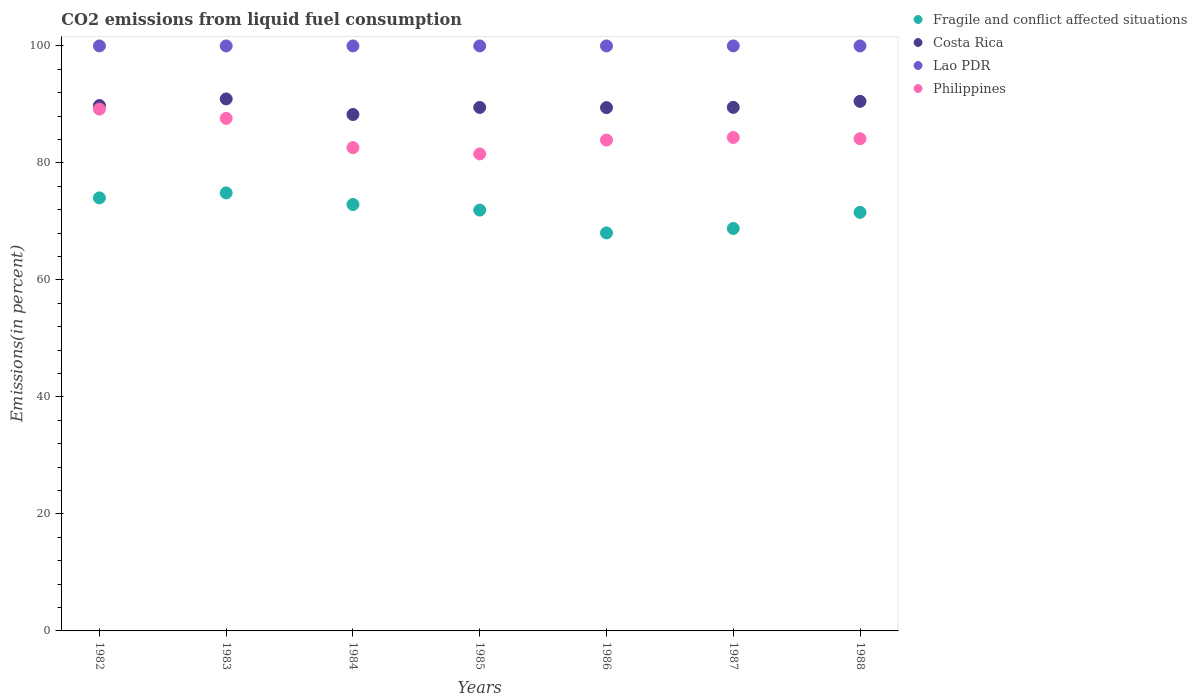How many different coloured dotlines are there?
Offer a very short reply. 4. What is the total CO2 emitted in Costa Rica in 1988?
Your response must be concise. 90.52. Across all years, what is the maximum total CO2 emitted in Fragile and conflict affected situations?
Make the answer very short. 74.87. Across all years, what is the minimum total CO2 emitted in Fragile and conflict affected situations?
Offer a terse response. 68.04. What is the total total CO2 emitted in Fragile and conflict affected situations in the graph?
Offer a terse response. 502.1. What is the difference between the total CO2 emitted in Fragile and conflict affected situations in 1985 and that in 1986?
Provide a short and direct response. 3.9. What is the difference between the total CO2 emitted in Philippines in 1988 and the total CO2 emitted in Fragile and conflict affected situations in 1986?
Make the answer very short. 16.1. What is the average total CO2 emitted in Costa Rica per year?
Ensure brevity in your answer.  89.71. In the year 1983, what is the difference between the total CO2 emitted in Costa Rica and total CO2 emitted in Fragile and conflict affected situations?
Offer a terse response. 16.07. In how many years, is the total CO2 emitted in Lao PDR greater than 68 %?
Your answer should be very brief. 7. What is the ratio of the total CO2 emitted in Costa Rica in 1983 to that in 1988?
Offer a terse response. 1. Is the difference between the total CO2 emitted in Costa Rica in 1983 and 1984 greater than the difference between the total CO2 emitted in Fragile and conflict affected situations in 1983 and 1984?
Provide a succinct answer. Yes. What is the difference between the highest and the second highest total CO2 emitted in Costa Rica?
Offer a very short reply. 0.42. What is the difference between the highest and the lowest total CO2 emitted in Philippines?
Give a very brief answer. 7.66. In how many years, is the total CO2 emitted in Philippines greater than the average total CO2 emitted in Philippines taken over all years?
Provide a short and direct response. 2. Is the sum of the total CO2 emitted in Philippines in 1984 and 1986 greater than the maximum total CO2 emitted in Costa Rica across all years?
Your response must be concise. Yes. Is it the case that in every year, the sum of the total CO2 emitted in Lao PDR and total CO2 emitted in Philippines  is greater than the sum of total CO2 emitted in Costa Rica and total CO2 emitted in Fragile and conflict affected situations?
Make the answer very short. Yes. Is the total CO2 emitted in Lao PDR strictly greater than the total CO2 emitted in Fragile and conflict affected situations over the years?
Provide a short and direct response. Yes. Is the total CO2 emitted in Philippines strictly less than the total CO2 emitted in Costa Rica over the years?
Your response must be concise. Yes. Does the graph contain grids?
Provide a succinct answer. No. Where does the legend appear in the graph?
Your answer should be compact. Top right. How many legend labels are there?
Your answer should be compact. 4. How are the legend labels stacked?
Keep it short and to the point. Vertical. What is the title of the graph?
Make the answer very short. CO2 emissions from liquid fuel consumption. Does "Lithuania" appear as one of the legend labels in the graph?
Ensure brevity in your answer.  No. What is the label or title of the Y-axis?
Offer a very short reply. Emissions(in percent). What is the Emissions(in percent) of Fragile and conflict affected situations in 1982?
Offer a very short reply. 74.03. What is the Emissions(in percent) of Costa Rica in 1982?
Make the answer very short. 89.81. What is the Emissions(in percent) of Lao PDR in 1982?
Offer a terse response. 100. What is the Emissions(in percent) in Philippines in 1982?
Offer a terse response. 89.2. What is the Emissions(in percent) in Fragile and conflict affected situations in 1983?
Offer a very short reply. 74.87. What is the Emissions(in percent) of Costa Rica in 1983?
Give a very brief answer. 90.94. What is the Emissions(in percent) in Philippines in 1983?
Keep it short and to the point. 87.62. What is the Emissions(in percent) of Fragile and conflict affected situations in 1984?
Give a very brief answer. 72.89. What is the Emissions(in percent) in Costa Rica in 1984?
Your answer should be very brief. 88.28. What is the Emissions(in percent) in Philippines in 1984?
Provide a succinct answer. 82.62. What is the Emissions(in percent) in Fragile and conflict affected situations in 1985?
Provide a short and direct response. 71.94. What is the Emissions(in percent) of Costa Rica in 1985?
Your answer should be compact. 89.48. What is the Emissions(in percent) of Philippines in 1985?
Your response must be concise. 81.54. What is the Emissions(in percent) in Fragile and conflict affected situations in 1986?
Keep it short and to the point. 68.04. What is the Emissions(in percent) in Costa Rica in 1986?
Your answer should be compact. 89.45. What is the Emissions(in percent) of Philippines in 1986?
Offer a terse response. 83.9. What is the Emissions(in percent) in Fragile and conflict affected situations in 1987?
Keep it short and to the point. 68.79. What is the Emissions(in percent) of Costa Rica in 1987?
Your response must be concise. 89.49. What is the Emissions(in percent) in Philippines in 1987?
Offer a very short reply. 84.35. What is the Emissions(in percent) of Fragile and conflict affected situations in 1988?
Your response must be concise. 71.55. What is the Emissions(in percent) in Costa Rica in 1988?
Ensure brevity in your answer.  90.52. What is the Emissions(in percent) in Lao PDR in 1988?
Your answer should be compact. 100. What is the Emissions(in percent) in Philippines in 1988?
Make the answer very short. 84.14. Across all years, what is the maximum Emissions(in percent) in Fragile and conflict affected situations?
Keep it short and to the point. 74.87. Across all years, what is the maximum Emissions(in percent) in Costa Rica?
Give a very brief answer. 90.94. Across all years, what is the maximum Emissions(in percent) in Lao PDR?
Your answer should be compact. 100. Across all years, what is the maximum Emissions(in percent) in Philippines?
Give a very brief answer. 89.2. Across all years, what is the minimum Emissions(in percent) in Fragile and conflict affected situations?
Provide a short and direct response. 68.04. Across all years, what is the minimum Emissions(in percent) in Costa Rica?
Make the answer very short. 88.28. Across all years, what is the minimum Emissions(in percent) of Philippines?
Keep it short and to the point. 81.54. What is the total Emissions(in percent) in Fragile and conflict affected situations in the graph?
Provide a short and direct response. 502.11. What is the total Emissions(in percent) of Costa Rica in the graph?
Provide a short and direct response. 627.98. What is the total Emissions(in percent) in Lao PDR in the graph?
Provide a succinct answer. 700. What is the total Emissions(in percent) in Philippines in the graph?
Offer a terse response. 593.37. What is the difference between the Emissions(in percent) of Fragile and conflict affected situations in 1982 and that in 1983?
Provide a succinct answer. -0.85. What is the difference between the Emissions(in percent) of Costa Rica in 1982 and that in 1983?
Your answer should be very brief. -1.13. What is the difference between the Emissions(in percent) of Lao PDR in 1982 and that in 1983?
Provide a short and direct response. 0. What is the difference between the Emissions(in percent) of Philippines in 1982 and that in 1983?
Provide a succinct answer. 1.58. What is the difference between the Emissions(in percent) of Fragile and conflict affected situations in 1982 and that in 1984?
Ensure brevity in your answer.  1.13. What is the difference between the Emissions(in percent) in Costa Rica in 1982 and that in 1984?
Make the answer very short. 1.53. What is the difference between the Emissions(in percent) in Lao PDR in 1982 and that in 1984?
Your response must be concise. 0. What is the difference between the Emissions(in percent) in Philippines in 1982 and that in 1984?
Offer a very short reply. 6.58. What is the difference between the Emissions(in percent) of Fragile and conflict affected situations in 1982 and that in 1985?
Provide a short and direct response. 2.09. What is the difference between the Emissions(in percent) in Costa Rica in 1982 and that in 1985?
Ensure brevity in your answer.  0.32. What is the difference between the Emissions(in percent) of Lao PDR in 1982 and that in 1985?
Your answer should be compact. 0. What is the difference between the Emissions(in percent) in Philippines in 1982 and that in 1985?
Provide a succinct answer. 7.66. What is the difference between the Emissions(in percent) of Fragile and conflict affected situations in 1982 and that in 1986?
Ensure brevity in your answer.  5.99. What is the difference between the Emissions(in percent) of Costa Rica in 1982 and that in 1986?
Offer a very short reply. 0.36. What is the difference between the Emissions(in percent) in Lao PDR in 1982 and that in 1986?
Your answer should be very brief. 0. What is the difference between the Emissions(in percent) in Philippines in 1982 and that in 1986?
Your response must be concise. 5.29. What is the difference between the Emissions(in percent) of Fragile and conflict affected situations in 1982 and that in 1987?
Offer a very short reply. 5.23. What is the difference between the Emissions(in percent) in Costa Rica in 1982 and that in 1987?
Offer a terse response. 0.31. What is the difference between the Emissions(in percent) in Philippines in 1982 and that in 1987?
Provide a succinct answer. 4.85. What is the difference between the Emissions(in percent) in Fragile and conflict affected situations in 1982 and that in 1988?
Your response must be concise. 2.48. What is the difference between the Emissions(in percent) of Costa Rica in 1982 and that in 1988?
Your answer should be compact. -0.72. What is the difference between the Emissions(in percent) of Philippines in 1982 and that in 1988?
Your response must be concise. 5.06. What is the difference between the Emissions(in percent) of Fragile and conflict affected situations in 1983 and that in 1984?
Ensure brevity in your answer.  1.98. What is the difference between the Emissions(in percent) in Costa Rica in 1983 and that in 1984?
Give a very brief answer. 2.66. What is the difference between the Emissions(in percent) of Philippines in 1983 and that in 1984?
Your response must be concise. 5. What is the difference between the Emissions(in percent) in Fragile and conflict affected situations in 1983 and that in 1985?
Ensure brevity in your answer.  2.94. What is the difference between the Emissions(in percent) in Costa Rica in 1983 and that in 1985?
Give a very brief answer. 1.46. What is the difference between the Emissions(in percent) of Lao PDR in 1983 and that in 1985?
Give a very brief answer. 0. What is the difference between the Emissions(in percent) of Philippines in 1983 and that in 1985?
Your answer should be very brief. 6.08. What is the difference between the Emissions(in percent) of Fragile and conflict affected situations in 1983 and that in 1986?
Ensure brevity in your answer.  6.84. What is the difference between the Emissions(in percent) in Costa Rica in 1983 and that in 1986?
Provide a short and direct response. 1.49. What is the difference between the Emissions(in percent) of Lao PDR in 1983 and that in 1986?
Offer a very short reply. 0. What is the difference between the Emissions(in percent) in Philippines in 1983 and that in 1986?
Give a very brief answer. 3.71. What is the difference between the Emissions(in percent) of Fragile and conflict affected situations in 1983 and that in 1987?
Keep it short and to the point. 6.08. What is the difference between the Emissions(in percent) in Costa Rica in 1983 and that in 1987?
Keep it short and to the point. 1.45. What is the difference between the Emissions(in percent) in Lao PDR in 1983 and that in 1987?
Ensure brevity in your answer.  0. What is the difference between the Emissions(in percent) of Philippines in 1983 and that in 1987?
Ensure brevity in your answer.  3.27. What is the difference between the Emissions(in percent) in Fragile and conflict affected situations in 1983 and that in 1988?
Ensure brevity in your answer.  3.33. What is the difference between the Emissions(in percent) in Costa Rica in 1983 and that in 1988?
Provide a short and direct response. 0.42. What is the difference between the Emissions(in percent) in Philippines in 1983 and that in 1988?
Make the answer very short. 3.48. What is the difference between the Emissions(in percent) of Fragile and conflict affected situations in 1984 and that in 1985?
Your answer should be very brief. 0.96. What is the difference between the Emissions(in percent) of Costa Rica in 1984 and that in 1985?
Offer a very short reply. -1.2. What is the difference between the Emissions(in percent) in Philippines in 1984 and that in 1985?
Provide a short and direct response. 1.08. What is the difference between the Emissions(in percent) in Fragile and conflict affected situations in 1984 and that in 1986?
Your answer should be compact. 4.85. What is the difference between the Emissions(in percent) in Costa Rica in 1984 and that in 1986?
Keep it short and to the point. -1.17. What is the difference between the Emissions(in percent) of Philippines in 1984 and that in 1986?
Your answer should be very brief. -1.29. What is the difference between the Emissions(in percent) of Fragile and conflict affected situations in 1984 and that in 1987?
Offer a terse response. 4.1. What is the difference between the Emissions(in percent) of Costa Rica in 1984 and that in 1987?
Give a very brief answer. -1.22. What is the difference between the Emissions(in percent) in Philippines in 1984 and that in 1987?
Offer a very short reply. -1.73. What is the difference between the Emissions(in percent) in Fragile and conflict affected situations in 1984 and that in 1988?
Offer a terse response. 1.35. What is the difference between the Emissions(in percent) of Costa Rica in 1984 and that in 1988?
Offer a terse response. -2.25. What is the difference between the Emissions(in percent) of Lao PDR in 1984 and that in 1988?
Provide a succinct answer. 0. What is the difference between the Emissions(in percent) in Philippines in 1984 and that in 1988?
Ensure brevity in your answer.  -1.52. What is the difference between the Emissions(in percent) in Fragile and conflict affected situations in 1985 and that in 1986?
Give a very brief answer. 3.9. What is the difference between the Emissions(in percent) of Costa Rica in 1985 and that in 1986?
Your answer should be very brief. 0.03. What is the difference between the Emissions(in percent) of Lao PDR in 1985 and that in 1986?
Make the answer very short. 0. What is the difference between the Emissions(in percent) in Philippines in 1985 and that in 1986?
Your answer should be compact. -2.36. What is the difference between the Emissions(in percent) in Fragile and conflict affected situations in 1985 and that in 1987?
Offer a very short reply. 3.14. What is the difference between the Emissions(in percent) of Costa Rica in 1985 and that in 1987?
Your answer should be very brief. -0.01. What is the difference between the Emissions(in percent) in Philippines in 1985 and that in 1987?
Provide a short and direct response. -2.81. What is the difference between the Emissions(in percent) in Fragile and conflict affected situations in 1985 and that in 1988?
Offer a terse response. 0.39. What is the difference between the Emissions(in percent) in Costa Rica in 1985 and that in 1988?
Offer a terse response. -1.04. What is the difference between the Emissions(in percent) in Lao PDR in 1985 and that in 1988?
Your answer should be very brief. 0. What is the difference between the Emissions(in percent) of Philippines in 1985 and that in 1988?
Offer a very short reply. -2.6. What is the difference between the Emissions(in percent) in Fragile and conflict affected situations in 1986 and that in 1987?
Your answer should be compact. -0.76. What is the difference between the Emissions(in percent) in Costa Rica in 1986 and that in 1987?
Provide a short and direct response. -0.04. What is the difference between the Emissions(in percent) of Lao PDR in 1986 and that in 1987?
Provide a succinct answer. 0. What is the difference between the Emissions(in percent) in Philippines in 1986 and that in 1987?
Your answer should be very brief. -0.44. What is the difference between the Emissions(in percent) in Fragile and conflict affected situations in 1986 and that in 1988?
Keep it short and to the point. -3.51. What is the difference between the Emissions(in percent) in Costa Rica in 1986 and that in 1988?
Provide a short and direct response. -1.07. What is the difference between the Emissions(in percent) of Lao PDR in 1986 and that in 1988?
Give a very brief answer. 0. What is the difference between the Emissions(in percent) of Philippines in 1986 and that in 1988?
Your answer should be compact. -0.23. What is the difference between the Emissions(in percent) of Fragile and conflict affected situations in 1987 and that in 1988?
Provide a succinct answer. -2.75. What is the difference between the Emissions(in percent) in Costa Rica in 1987 and that in 1988?
Your answer should be very brief. -1.03. What is the difference between the Emissions(in percent) in Philippines in 1987 and that in 1988?
Offer a very short reply. 0.21. What is the difference between the Emissions(in percent) in Fragile and conflict affected situations in 1982 and the Emissions(in percent) in Costa Rica in 1983?
Your response must be concise. -16.92. What is the difference between the Emissions(in percent) in Fragile and conflict affected situations in 1982 and the Emissions(in percent) in Lao PDR in 1983?
Give a very brief answer. -25.97. What is the difference between the Emissions(in percent) in Fragile and conflict affected situations in 1982 and the Emissions(in percent) in Philippines in 1983?
Make the answer very short. -13.59. What is the difference between the Emissions(in percent) of Costa Rica in 1982 and the Emissions(in percent) of Lao PDR in 1983?
Your response must be concise. -10.19. What is the difference between the Emissions(in percent) in Costa Rica in 1982 and the Emissions(in percent) in Philippines in 1983?
Your answer should be very brief. 2.19. What is the difference between the Emissions(in percent) of Lao PDR in 1982 and the Emissions(in percent) of Philippines in 1983?
Your response must be concise. 12.38. What is the difference between the Emissions(in percent) of Fragile and conflict affected situations in 1982 and the Emissions(in percent) of Costa Rica in 1984?
Ensure brevity in your answer.  -14.25. What is the difference between the Emissions(in percent) in Fragile and conflict affected situations in 1982 and the Emissions(in percent) in Lao PDR in 1984?
Ensure brevity in your answer.  -25.97. What is the difference between the Emissions(in percent) of Fragile and conflict affected situations in 1982 and the Emissions(in percent) of Philippines in 1984?
Offer a terse response. -8.59. What is the difference between the Emissions(in percent) of Costa Rica in 1982 and the Emissions(in percent) of Lao PDR in 1984?
Ensure brevity in your answer.  -10.19. What is the difference between the Emissions(in percent) in Costa Rica in 1982 and the Emissions(in percent) in Philippines in 1984?
Make the answer very short. 7.19. What is the difference between the Emissions(in percent) of Lao PDR in 1982 and the Emissions(in percent) of Philippines in 1984?
Your response must be concise. 17.38. What is the difference between the Emissions(in percent) of Fragile and conflict affected situations in 1982 and the Emissions(in percent) of Costa Rica in 1985?
Your answer should be compact. -15.46. What is the difference between the Emissions(in percent) in Fragile and conflict affected situations in 1982 and the Emissions(in percent) in Lao PDR in 1985?
Offer a terse response. -25.97. What is the difference between the Emissions(in percent) of Fragile and conflict affected situations in 1982 and the Emissions(in percent) of Philippines in 1985?
Your response must be concise. -7.51. What is the difference between the Emissions(in percent) in Costa Rica in 1982 and the Emissions(in percent) in Lao PDR in 1985?
Provide a short and direct response. -10.19. What is the difference between the Emissions(in percent) in Costa Rica in 1982 and the Emissions(in percent) in Philippines in 1985?
Your response must be concise. 8.27. What is the difference between the Emissions(in percent) of Lao PDR in 1982 and the Emissions(in percent) of Philippines in 1985?
Offer a terse response. 18.46. What is the difference between the Emissions(in percent) of Fragile and conflict affected situations in 1982 and the Emissions(in percent) of Costa Rica in 1986?
Offer a terse response. -15.43. What is the difference between the Emissions(in percent) in Fragile and conflict affected situations in 1982 and the Emissions(in percent) in Lao PDR in 1986?
Provide a succinct answer. -25.97. What is the difference between the Emissions(in percent) in Fragile and conflict affected situations in 1982 and the Emissions(in percent) in Philippines in 1986?
Your answer should be very brief. -9.88. What is the difference between the Emissions(in percent) of Costa Rica in 1982 and the Emissions(in percent) of Lao PDR in 1986?
Ensure brevity in your answer.  -10.19. What is the difference between the Emissions(in percent) of Costa Rica in 1982 and the Emissions(in percent) of Philippines in 1986?
Give a very brief answer. 5.9. What is the difference between the Emissions(in percent) in Lao PDR in 1982 and the Emissions(in percent) in Philippines in 1986?
Offer a very short reply. 16.1. What is the difference between the Emissions(in percent) of Fragile and conflict affected situations in 1982 and the Emissions(in percent) of Costa Rica in 1987?
Provide a succinct answer. -15.47. What is the difference between the Emissions(in percent) of Fragile and conflict affected situations in 1982 and the Emissions(in percent) of Lao PDR in 1987?
Give a very brief answer. -25.97. What is the difference between the Emissions(in percent) in Fragile and conflict affected situations in 1982 and the Emissions(in percent) in Philippines in 1987?
Ensure brevity in your answer.  -10.32. What is the difference between the Emissions(in percent) in Costa Rica in 1982 and the Emissions(in percent) in Lao PDR in 1987?
Ensure brevity in your answer.  -10.19. What is the difference between the Emissions(in percent) of Costa Rica in 1982 and the Emissions(in percent) of Philippines in 1987?
Your answer should be very brief. 5.46. What is the difference between the Emissions(in percent) of Lao PDR in 1982 and the Emissions(in percent) of Philippines in 1987?
Your response must be concise. 15.65. What is the difference between the Emissions(in percent) in Fragile and conflict affected situations in 1982 and the Emissions(in percent) in Costa Rica in 1988?
Keep it short and to the point. -16.5. What is the difference between the Emissions(in percent) in Fragile and conflict affected situations in 1982 and the Emissions(in percent) in Lao PDR in 1988?
Offer a terse response. -25.97. What is the difference between the Emissions(in percent) of Fragile and conflict affected situations in 1982 and the Emissions(in percent) of Philippines in 1988?
Offer a very short reply. -10.11. What is the difference between the Emissions(in percent) of Costa Rica in 1982 and the Emissions(in percent) of Lao PDR in 1988?
Make the answer very short. -10.19. What is the difference between the Emissions(in percent) in Costa Rica in 1982 and the Emissions(in percent) in Philippines in 1988?
Provide a short and direct response. 5.67. What is the difference between the Emissions(in percent) in Lao PDR in 1982 and the Emissions(in percent) in Philippines in 1988?
Make the answer very short. 15.86. What is the difference between the Emissions(in percent) of Fragile and conflict affected situations in 1983 and the Emissions(in percent) of Costa Rica in 1984?
Offer a very short reply. -13.4. What is the difference between the Emissions(in percent) of Fragile and conflict affected situations in 1983 and the Emissions(in percent) of Lao PDR in 1984?
Give a very brief answer. -25.13. What is the difference between the Emissions(in percent) of Fragile and conflict affected situations in 1983 and the Emissions(in percent) of Philippines in 1984?
Your response must be concise. -7.75. What is the difference between the Emissions(in percent) in Costa Rica in 1983 and the Emissions(in percent) in Lao PDR in 1984?
Keep it short and to the point. -9.06. What is the difference between the Emissions(in percent) of Costa Rica in 1983 and the Emissions(in percent) of Philippines in 1984?
Your answer should be very brief. 8.32. What is the difference between the Emissions(in percent) of Lao PDR in 1983 and the Emissions(in percent) of Philippines in 1984?
Keep it short and to the point. 17.38. What is the difference between the Emissions(in percent) of Fragile and conflict affected situations in 1983 and the Emissions(in percent) of Costa Rica in 1985?
Provide a succinct answer. -14.61. What is the difference between the Emissions(in percent) of Fragile and conflict affected situations in 1983 and the Emissions(in percent) of Lao PDR in 1985?
Your response must be concise. -25.13. What is the difference between the Emissions(in percent) in Fragile and conflict affected situations in 1983 and the Emissions(in percent) in Philippines in 1985?
Offer a terse response. -6.67. What is the difference between the Emissions(in percent) in Costa Rica in 1983 and the Emissions(in percent) in Lao PDR in 1985?
Make the answer very short. -9.06. What is the difference between the Emissions(in percent) of Costa Rica in 1983 and the Emissions(in percent) of Philippines in 1985?
Provide a succinct answer. 9.4. What is the difference between the Emissions(in percent) in Lao PDR in 1983 and the Emissions(in percent) in Philippines in 1985?
Provide a short and direct response. 18.46. What is the difference between the Emissions(in percent) in Fragile and conflict affected situations in 1983 and the Emissions(in percent) in Costa Rica in 1986?
Give a very brief answer. -14.58. What is the difference between the Emissions(in percent) of Fragile and conflict affected situations in 1983 and the Emissions(in percent) of Lao PDR in 1986?
Offer a terse response. -25.13. What is the difference between the Emissions(in percent) in Fragile and conflict affected situations in 1983 and the Emissions(in percent) in Philippines in 1986?
Make the answer very short. -9.03. What is the difference between the Emissions(in percent) in Costa Rica in 1983 and the Emissions(in percent) in Lao PDR in 1986?
Your answer should be very brief. -9.06. What is the difference between the Emissions(in percent) in Costa Rica in 1983 and the Emissions(in percent) in Philippines in 1986?
Give a very brief answer. 7.04. What is the difference between the Emissions(in percent) in Lao PDR in 1983 and the Emissions(in percent) in Philippines in 1986?
Ensure brevity in your answer.  16.1. What is the difference between the Emissions(in percent) of Fragile and conflict affected situations in 1983 and the Emissions(in percent) of Costa Rica in 1987?
Make the answer very short. -14.62. What is the difference between the Emissions(in percent) of Fragile and conflict affected situations in 1983 and the Emissions(in percent) of Lao PDR in 1987?
Offer a terse response. -25.13. What is the difference between the Emissions(in percent) in Fragile and conflict affected situations in 1983 and the Emissions(in percent) in Philippines in 1987?
Ensure brevity in your answer.  -9.47. What is the difference between the Emissions(in percent) of Costa Rica in 1983 and the Emissions(in percent) of Lao PDR in 1987?
Your answer should be compact. -9.06. What is the difference between the Emissions(in percent) in Costa Rica in 1983 and the Emissions(in percent) in Philippines in 1987?
Offer a terse response. 6.59. What is the difference between the Emissions(in percent) of Lao PDR in 1983 and the Emissions(in percent) of Philippines in 1987?
Your response must be concise. 15.65. What is the difference between the Emissions(in percent) of Fragile and conflict affected situations in 1983 and the Emissions(in percent) of Costa Rica in 1988?
Give a very brief answer. -15.65. What is the difference between the Emissions(in percent) of Fragile and conflict affected situations in 1983 and the Emissions(in percent) of Lao PDR in 1988?
Give a very brief answer. -25.13. What is the difference between the Emissions(in percent) of Fragile and conflict affected situations in 1983 and the Emissions(in percent) of Philippines in 1988?
Offer a very short reply. -9.26. What is the difference between the Emissions(in percent) in Costa Rica in 1983 and the Emissions(in percent) in Lao PDR in 1988?
Offer a terse response. -9.06. What is the difference between the Emissions(in percent) in Costa Rica in 1983 and the Emissions(in percent) in Philippines in 1988?
Give a very brief answer. 6.8. What is the difference between the Emissions(in percent) of Lao PDR in 1983 and the Emissions(in percent) of Philippines in 1988?
Your answer should be compact. 15.86. What is the difference between the Emissions(in percent) in Fragile and conflict affected situations in 1984 and the Emissions(in percent) in Costa Rica in 1985?
Offer a terse response. -16.59. What is the difference between the Emissions(in percent) in Fragile and conflict affected situations in 1984 and the Emissions(in percent) in Lao PDR in 1985?
Give a very brief answer. -27.11. What is the difference between the Emissions(in percent) of Fragile and conflict affected situations in 1984 and the Emissions(in percent) of Philippines in 1985?
Your response must be concise. -8.65. What is the difference between the Emissions(in percent) in Costa Rica in 1984 and the Emissions(in percent) in Lao PDR in 1985?
Ensure brevity in your answer.  -11.72. What is the difference between the Emissions(in percent) in Costa Rica in 1984 and the Emissions(in percent) in Philippines in 1985?
Make the answer very short. 6.74. What is the difference between the Emissions(in percent) in Lao PDR in 1984 and the Emissions(in percent) in Philippines in 1985?
Ensure brevity in your answer.  18.46. What is the difference between the Emissions(in percent) of Fragile and conflict affected situations in 1984 and the Emissions(in percent) of Costa Rica in 1986?
Make the answer very short. -16.56. What is the difference between the Emissions(in percent) in Fragile and conflict affected situations in 1984 and the Emissions(in percent) in Lao PDR in 1986?
Ensure brevity in your answer.  -27.11. What is the difference between the Emissions(in percent) in Fragile and conflict affected situations in 1984 and the Emissions(in percent) in Philippines in 1986?
Offer a terse response. -11.01. What is the difference between the Emissions(in percent) in Costa Rica in 1984 and the Emissions(in percent) in Lao PDR in 1986?
Keep it short and to the point. -11.72. What is the difference between the Emissions(in percent) in Costa Rica in 1984 and the Emissions(in percent) in Philippines in 1986?
Provide a short and direct response. 4.37. What is the difference between the Emissions(in percent) in Lao PDR in 1984 and the Emissions(in percent) in Philippines in 1986?
Offer a terse response. 16.1. What is the difference between the Emissions(in percent) in Fragile and conflict affected situations in 1984 and the Emissions(in percent) in Costa Rica in 1987?
Provide a succinct answer. -16.6. What is the difference between the Emissions(in percent) of Fragile and conflict affected situations in 1984 and the Emissions(in percent) of Lao PDR in 1987?
Your answer should be very brief. -27.11. What is the difference between the Emissions(in percent) of Fragile and conflict affected situations in 1984 and the Emissions(in percent) of Philippines in 1987?
Your answer should be very brief. -11.46. What is the difference between the Emissions(in percent) of Costa Rica in 1984 and the Emissions(in percent) of Lao PDR in 1987?
Give a very brief answer. -11.72. What is the difference between the Emissions(in percent) in Costa Rica in 1984 and the Emissions(in percent) in Philippines in 1987?
Your answer should be very brief. 3.93. What is the difference between the Emissions(in percent) in Lao PDR in 1984 and the Emissions(in percent) in Philippines in 1987?
Provide a succinct answer. 15.65. What is the difference between the Emissions(in percent) in Fragile and conflict affected situations in 1984 and the Emissions(in percent) in Costa Rica in 1988?
Your answer should be compact. -17.63. What is the difference between the Emissions(in percent) in Fragile and conflict affected situations in 1984 and the Emissions(in percent) in Lao PDR in 1988?
Ensure brevity in your answer.  -27.11. What is the difference between the Emissions(in percent) in Fragile and conflict affected situations in 1984 and the Emissions(in percent) in Philippines in 1988?
Offer a very short reply. -11.25. What is the difference between the Emissions(in percent) of Costa Rica in 1984 and the Emissions(in percent) of Lao PDR in 1988?
Keep it short and to the point. -11.72. What is the difference between the Emissions(in percent) of Costa Rica in 1984 and the Emissions(in percent) of Philippines in 1988?
Keep it short and to the point. 4.14. What is the difference between the Emissions(in percent) in Lao PDR in 1984 and the Emissions(in percent) in Philippines in 1988?
Provide a succinct answer. 15.86. What is the difference between the Emissions(in percent) of Fragile and conflict affected situations in 1985 and the Emissions(in percent) of Costa Rica in 1986?
Keep it short and to the point. -17.51. What is the difference between the Emissions(in percent) in Fragile and conflict affected situations in 1985 and the Emissions(in percent) in Lao PDR in 1986?
Offer a terse response. -28.06. What is the difference between the Emissions(in percent) of Fragile and conflict affected situations in 1985 and the Emissions(in percent) of Philippines in 1986?
Ensure brevity in your answer.  -11.97. What is the difference between the Emissions(in percent) in Costa Rica in 1985 and the Emissions(in percent) in Lao PDR in 1986?
Keep it short and to the point. -10.52. What is the difference between the Emissions(in percent) in Costa Rica in 1985 and the Emissions(in percent) in Philippines in 1986?
Your response must be concise. 5.58. What is the difference between the Emissions(in percent) of Lao PDR in 1985 and the Emissions(in percent) of Philippines in 1986?
Your response must be concise. 16.1. What is the difference between the Emissions(in percent) of Fragile and conflict affected situations in 1985 and the Emissions(in percent) of Costa Rica in 1987?
Give a very brief answer. -17.56. What is the difference between the Emissions(in percent) of Fragile and conflict affected situations in 1985 and the Emissions(in percent) of Lao PDR in 1987?
Offer a very short reply. -28.06. What is the difference between the Emissions(in percent) of Fragile and conflict affected situations in 1985 and the Emissions(in percent) of Philippines in 1987?
Make the answer very short. -12.41. What is the difference between the Emissions(in percent) of Costa Rica in 1985 and the Emissions(in percent) of Lao PDR in 1987?
Provide a short and direct response. -10.52. What is the difference between the Emissions(in percent) of Costa Rica in 1985 and the Emissions(in percent) of Philippines in 1987?
Your answer should be very brief. 5.13. What is the difference between the Emissions(in percent) in Lao PDR in 1985 and the Emissions(in percent) in Philippines in 1987?
Your answer should be very brief. 15.65. What is the difference between the Emissions(in percent) in Fragile and conflict affected situations in 1985 and the Emissions(in percent) in Costa Rica in 1988?
Provide a short and direct response. -18.59. What is the difference between the Emissions(in percent) in Fragile and conflict affected situations in 1985 and the Emissions(in percent) in Lao PDR in 1988?
Make the answer very short. -28.06. What is the difference between the Emissions(in percent) in Fragile and conflict affected situations in 1985 and the Emissions(in percent) in Philippines in 1988?
Provide a succinct answer. -12.2. What is the difference between the Emissions(in percent) in Costa Rica in 1985 and the Emissions(in percent) in Lao PDR in 1988?
Give a very brief answer. -10.52. What is the difference between the Emissions(in percent) in Costa Rica in 1985 and the Emissions(in percent) in Philippines in 1988?
Make the answer very short. 5.34. What is the difference between the Emissions(in percent) in Lao PDR in 1985 and the Emissions(in percent) in Philippines in 1988?
Provide a succinct answer. 15.86. What is the difference between the Emissions(in percent) of Fragile and conflict affected situations in 1986 and the Emissions(in percent) of Costa Rica in 1987?
Your answer should be compact. -21.46. What is the difference between the Emissions(in percent) of Fragile and conflict affected situations in 1986 and the Emissions(in percent) of Lao PDR in 1987?
Offer a terse response. -31.96. What is the difference between the Emissions(in percent) of Fragile and conflict affected situations in 1986 and the Emissions(in percent) of Philippines in 1987?
Ensure brevity in your answer.  -16.31. What is the difference between the Emissions(in percent) in Costa Rica in 1986 and the Emissions(in percent) in Lao PDR in 1987?
Offer a terse response. -10.55. What is the difference between the Emissions(in percent) in Costa Rica in 1986 and the Emissions(in percent) in Philippines in 1987?
Offer a terse response. 5.1. What is the difference between the Emissions(in percent) in Lao PDR in 1986 and the Emissions(in percent) in Philippines in 1987?
Your answer should be compact. 15.65. What is the difference between the Emissions(in percent) in Fragile and conflict affected situations in 1986 and the Emissions(in percent) in Costa Rica in 1988?
Give a very brief answer. -22.49. What is the difference between the Emissions(in percent) of Fragile and conflict affected situations in 1986 and the Emissions(in percent) of Lao PDR in 1988?
Provide a short and direct response. -31.96. What is the difference between the Emissions(in percent) of Fragile and conflict affected situations in 1986 and the Emissions(in percent) of Philippines in 1988?
Provide a succinct answer. -16.1. What is the difference between the Emissions(in percent) in Costa Rica in 1986 and the Emissions(in percent) in Lao PDR in 1988?
Make the answer very short. -10.55. What is the difference between the Emissions(in percent) of Costa Rica in 1986 and the Emissions(in percent) of Philippines in 1988?
Provide a short and direct response. 5.31. What is the difference between the Emissions(in percent) of Lao PDR in 1986 and the Emissions(in percent) of Philippines in 1988?
Your response must be concise. 15.86. What is the difference between the Emissions(in percent) in Fragile and conflict affected situations in 1987 and the Emissions(in percent) in Costa Rica in 1988?
Provide a short and direct response. -21.73. What is the difference between the Emissions(in percent) of Fragile and conflict affected situations in 1987 and the Emissions(in percent) of Lao PDR in 1988?
Provide a succinct answer. -31.21. What is the difference between the Emissions(in percent) in Fragile and conflict affected situations in 1987 and the Emissions(in percent) in Philippines in 1988?
Offer a terse response. -15.35. What is the difference between the Emissions(in percent) in Costa Rica in 1987 and the Emissions(in percent) in Lao PDR in 1988?
Offer a very short reply. -10.51. What is the difference between the Emissions(in percent) in Costa Rica in 1987 and the Emissions(in percent) in Philippines in 1988?
Ensure brevity in your answer.  5.36. What is the difference between the Emissions(in percent) of Lao PDR in 1987 and the Emissions(in percent) of Philippines in 1988?
Ensure brevity in your answer.  15.86. What is the average Emissions(in percent) of Fragile and conflict affected situations per year?
Ensure brevity in your answer.  71.73. What is the average Emissions(in percent) of Costa Rica per year?
Offer a very short reply. 89.71. What is the average Emissions(in percent) in Lao PDR per year?
Provide a succinct answer. 100. What is the average Emissions(in percent) of Philippines per year?
Your answer should be very brief. 84.77. In the year 1982, what is the difference between the Emissions(in percent) in Fragile and conflict affected situations and Emissions(in percent) in Costa Rica?
Your answer should be very brief. -15.78. In the year 1982, what is the difference between the Emissions(in percent) of Fragile and conflict affected situations and Emissions(in percent) of Lao PDR?
Make the answer very short. -25.97. In the year 1982, what is the difference between the Emissions(in percent) in Fragile and conflict affected situations and Emissions(in percent) in Philippines?
Keep it short and to the point. -15.17. In the year 1982, what is the difference between the Emissions(in percent) of Costa Rica and Emissions(in percent) of Lao PDR?
Offer a very short reply. -10.19. In the year 1982, what is the difference between the Emissions(in percent) of Costa Rica and Emissions(in percent) of Philippines?
Provide a succinct answer. 0.61. In the year 1982, what is the difference between the Emissions(in percent) in Lao PDR and Emissions(in percent) in Philippines?
Your response must be concise. 10.8. In the year 1983, what is the difference between the Emissions(in percent) of Fragile and conflict affected situations and Emissions(in percent) of Costa Rica?
Provide a short and direct response. -16.07. In the year 1983, what is the difference between the Emissions(in percent) in Fragile and conflict affected situations and Emissions(in percent) in Lao PDR?
Ensure brevity in your answer.  -25.13. In the year 1983, what is the difference between the Emissions(in percent) in Fragile and conflict affected situations and Emissions(in percent) in Philippines?
Your response must be concise. -12.74. In the year 1983, what is the difference between the Emissions(in percent) in Costa Rica and Emissions(in percent) in Lao PDR?
Your answer should be very brief. -9.06. In the year 1983, what is the difference between the Emissions(in percent) of Costa Rica and Emissions(in percent) of Philippines?
Offer a very short reply. 3.32. In the year 1983, what is the difference between the Emissions(in percent) of Lao PDR and Emissions(in percent) of Philippines?
Your answer should be compact. 12.38. In the year 1984, what is the difference between the Emissions(in percent) in Fragile and conflict affected situations and Emissions(in percent) in Costa Rica?
Ensure brevity in your answer.  -15.39. In the year 1984, what is the difference between the Emissions(in percent) in Fragile and conflict affected situations and Emissions(in percent) in Lao PDR?
Keep it short and to the point. -27.11. In the year 1984, what is the difference between the Emissions(in percent) in Fragile and conflict affected situations and Emissions(in percent) in Philippines?
Provide a short and direct response. -9.73. In the year 1984, what is the difference between the Emissions(in percent) of Costa Rica and Emissions(in percent) of Lao PDR?
Provide a short and direct response. -11.72. In the year 1984, what is the difference between the Emissions(in percent) of Costa Rica and Emissions(in percent) of Philippines?
Keep it short and to the point. 5.66. In the year 1984, what is the difference between the Emissions(in percent) of Lao PDR and Emissions(in percent) of Philippines?
Give a very brief answer. 17.38. In the year 1985, what is the difference between the Emissions(in percent) of Fragile and conflict affected situations and Emissions(in percent) of Costa Rica?
Provide a short and direct response. -17.55. In the year 1985, what is the difference between the Emissions(in percent) in Fragile and conflict affected situations and Emissions(in percent) in Lao PDR?
Your answer should be compact. -28.06. In the year 1985, what is the difference between the Emissions(in percent) of Fragile and conflict affected situations and Emissions(in percent) of Philippines?
Your answer should be very brief. -9.6. In the year 1985, what is the difference between the Emissions(in percent) in Costa Rica and Emissions(in percent) in Lao PDR?
Your answer should be compact. -10.52. In the year 1985, what is the difference between the Emissions(in percent) in Costa Rica and Emissions(in percent) in Philippines?
Your answer should be compact. 7.94. In the year 1985, what is the difference between the Emissions(in percent) in Lao PDR and Emissions(in percent) in Philippines?
Ensure brevity in your answer.  18.46. In the year 1986, what is the difference between the Emissions(in percent) in Fragile and conflict affected situations and Emissions(in percent) in Costa Rica?
Provide a short and direct response. -21.41. In the year 1986, what is the difference between the Emissions(in percent) of Fragile and conflict affected situations and Emissions(in percent) of Lao PDR?
Ensure brevity in your answer.  -31.96. In the year 1986, what is the difference between the Emissions(in percent) in Fragile and conflict affected situations and Emissions(in percent) in Philippines?
Make the answer very short. -15.87. In the year 1986, what is the difference between the Emissions(in percent) of Costa Rica and Emissions(in percent) of Lao PDR?
Provide a succinct answer. -10.55. In the year 1986, what is the difference between the Emissions(in percent) of Costa Rica and Emissions(in percent) of Philippines?
Offer a very short reply. 5.55. In the year 1986, what is the difference between the Emissions(in percent) of Lao PDR and Emissions(in percent) of Philippines?
Provide a short and direct response. 16.1. In the year 1987, what is the difference between the Emissions(in percent) of Fragile and conflict affected situations and Emissions(in percent) of Costa Rica?
Give a very brief answer. -20.7. In the year 1987, what is the difference between the Emissions(in percent) in Fragile and conflict affected situations and Emissions(in percent) in Lao PDR?
Make the answer very short. -31.21. In the year 1987, what is the difference between the Emissions(in percent) of Fragile and conflict affected situations and Emissions(in percent) of Philippines?
Your answer should be very brief. -15.56. In the year 1987, what is the difference between the Emissions(in percent) of Costa Rica and Emissions(in percent) of Lao PDR?
Provide a short and direct response. -10.51. In the year 1987, what is the difference between the Emissions(in percent) of Costa Rica and Emissions(in percent) of Philippines?
Offer a terse response. 5.15. In the year 1987, what is the difference between the Emissions(in percent) in Lao PDR and Emissions(in percent) in Philippines?
Your answer should be compact. 15.65. In the year 1988, what is the difference between the Emissions(in percent) of Fragile and conflict affected situations and Emissions(in percent) of Costa Rica?
Make the answer very short. -18.98. In the year 1988, what is the difference between the Emissions(in percent) in Fragile and conflict affected situations and Emissions(in percent) in Lao PDR?
Provide a short and direct response. -28.45. In the year 1988, what is the difference between the Emissions(in percent) in Fragile and conflict affected situations and Emissions(in percent) in Philippines?
Offer a terse response. -12.59. In the year 1988, what is the difference between the Emissions(in percent) in Costa Rica and Emissions(in percent) in Lao PDR?
Offer a very short reply. -9.48. In the year 1988, what is the difference between the Emissions(in percent) of Costa Rica and Emissions(in percent) of Philippines?
Ensure brevity in your answer.  6.39. In the year 1988, what is the difference between the Emissions(in percent) in Lao PDR and Emissions(in percent) in Philippines?
Your answer should be very brief. 15.86. What is the ratio of the Emissions(in percent) of Fragile and conflict affected situations in 1982 to that in 1983?
Provide a succinct answer. 0.99. What is the ratio of the Emissions(in percent) in Costa Rica in 1982 to that in 1983?
Give a very brief answer. 0.99. What is the ratio of the Emissions(in percent) in Lao PDR in 1982 to that in 1983?
Provide a succinct answer. 1. What is the ratio of the Emissions(in percent) in Fragile and conflict affected situations in 1982 to that in 1984?
Offer a very short reply. 1.02. What is the ratio of the Emissions(in percent) of Costa Rica in 1982 to that in 1984?
Give a very brief answer. 1.02. What is the ratio of the Emissions(in percent) in Lao PDR in 1982 to that in 1984?
Ensure brevity in your answer.  1. What is the ratio of the Emissions(in percent) in Philippines in 1982 to that in 1984?
Your answer should be very brief. 1.08. What is the ratio of the Emissions(in percent) of Fragile and conflict affected situations in 1982 to that in 1985?
Your answer should be very brief. 1.03. What is the ratio of the Emissions(in percent) in Philippines in 1982 to that in 1985?
Give a very brief answer. 1.09. What is the ratio of the Emissions(in percent) in Fragile and conflict affected situations in 1982 to that in 1986?
Give a very brief answer. 1.09. What is the ratio of the Emissions(in percent) in Lao PDR in 1982 to that in 1986?
Your answer should be very brief. 1. What is the ratio of the Emissions(in percent) of Philippines in 1982 to that in 1986?
Offer a very short reply. 1.06. What is the ratio of the Emissions(in percent) in Fragile and conflict affected situations in 1982 to that in 1987?
Your answer should be very brief. 1.08. What is the ratio of the Emissions(in percent) of Philippines in 1982 to that in 1987?
Keep it short and to the point. 1.06. What is the ratio of the Emissions(in percent) in Fragile and conflict affected situations in 1982 to that in 1988?
Your answer should be compact. 1.03. What is the ratio of the Emissions(in percent) in Costa Rica in 1982 to that in 1988?
Give a very brief answer. 0.99. What is the ratio of the Emissions(in percent) in Lao PDR in 1982 to that in 1988?
Provide a short and direct response. 1. What is the ratio of the Emissions(in percent) in Philippines in 1982 to that in 1988?
Provide a short and direct response. 1.06. What is the ratio of the Emissions(in percent) of Fragile and conflict affected situations in 1983 to that in 1984?
Keep it short and to the point. 1.03. What is the ratio of the Emissions(in percent) of Costa Rica in 1983 to that in 1984?
Keep it short and to the point. 1.03. What is the ratio of the Emissions(in percent) of Lao PDR in 1983 to that in 1984?
Your answer should be very brief. 1. What is the ratio of the Emissions(in percent) in Philippines in 1983 to that in 1984?
Offer a very short reply. 1.06. What is the ratio of the Emissions(in percent) in Fragile and conflict affected situations in 1983 to that in 1985?
Keep it short and to the point. 1.04. What is the ratio of the Emissions(in percent) in Costa Rica in 1983 to that in 1985?
Offer a terse response. 1.02. What is the ratio of the Emissions(in percent) of Lao PDR in 1983 to that in 1985?
Keep it short and to the point. 1. What is the ratio of the Emissions(in percent) of Philippines in 1983 to that in 1985?
Provide a succinct answer. 1.07. What is the ratio of the Emissions(in percent) of Fragile and conflict affected situations in 1983 to that in 1986?
Provide a short and direct response. 1.1. What is the ratio of the Emissions(in percent) in Costa Rica in 1983 to that in 1986?
Your answer should be compact. 1.02. What is the ratio of the Emissions(in percent) of Lao PDR in 1983 to that in 1986?
Give a very brief answer. 1. What is the ratio of the Emissions(in percent) of Philippines in 1983 to that in 1986?
Give a very brief answer. 1.04. What is the ratio of the Emissions(in percent) in Fragile and conflict affected situations in 1983 to that in 1987?
Offer a terse response. 1.09. What is the ratio of the Emissions(in percent) of Costa Rica in 1983 to that in 1987?
Provide a succinct answer. 1.02. What is the ratio of the Emissions(in percent) in Philippines in 1983 to that in 1987?
Ensure brevity in your answer.  1.04. What is the ratio of the Emissions(in percent) of Fragile and conflict affected situations in 1983 to that in 1988?
Provide a short and direct response. 1.05. What is the ratio of the Emissions(in percent) in Lao PDR in 1983 to that in 1988?
Offer a very short reply. 1. What is the ratio of the Emissions(in percent) of Philippines in 1983 to that in 1988?
Ensure brevity in your answer.  1.04. What is the ratio of the Emissions(in percent) in Fragile and conflict affected situations in 1984 to that in 1985?
Give a very brief answer. 1.01. What is the ratio of the Emissions(in percent) in Costa Rica in 1984 to that in 1985?
Ensure brevity in your answer.  0.99. What is the ratio of the Emissions(in percent) in Lao PDR in 1984 to that in 1985?
Make the answer very short. 1. What is the ratio of the Emissions(in percent) in Philippines in 1984 to that in 1985?
Keep it short and to the point. 1.01. What is the ratio of the Emissions(in percent) of Fragile and conflict affected situations in 1984 to that in 1986?
Give a very brief answer. 1.07. What is the ratio of the Emissions(in percent) of Costa Rica in 1984 to that in 1986?
Offer a very short reply. 0.99. What is the ratio of the Emissions(in percent) of Lao PDR in 1984 to that in 1986?
Provide a succinct answer. 1. What is the ratio of the Emissions(in percent) of Philippines in 1984 to that in 1986?
Ensure brevity in your answer.  0.98. What is the ratio of the Emissions(in percent) in Fragile and conflict affected situations in 1984 to that in 1987?
Give a very brief answer. 1.06. What is the ratio of the Emissions(in percent) in Costa Rica in 1984 to that in 1987?
Ensure brevity in your answer.  0.99. What is the ratio of the Emissions(in percent) of Philippines in 1984 to that in 1987?
Your response must be concise. 0.98. What is the ratio of the Emissions(in percent) of Fragile and conflict affected situations in 1984 to that in 1988?
Ensure brevity in your answer.  1.02. What is the ratio of the Emissions(in percent) in Costa Rica in 1984 to that in 1988?
Make the answer very short. 0.98. What is the ratio of the Emissions(in percent) in Philippines in 1984 to that in 1988?
Your answer should be very brief. 0.98. What is the ratio of the Emissions(in percent) in Fragile and conflict affected situations in 1985 to that in 1986?
Give a very brief answer. 1.06. What is the ratio of the Emissions(in percent) of Costa Rica in 1985 to that in 1986?
Provide a short and direct response. 1. What is the ratio of the Emissions(in percent) in Lao PDR in 1985 to that in 1986?
Ensure brevity in your answer.  1. What is the ratio of the Emissions(in percent) of Philippines in 1985 to that in 1986?
Your answer should be compact. 0.97. What is the ratio of the Emissions(in percent) of Fragile and conflict affected situations in 1985 to that in 1987?
Keep it short and to the point. 1.05. What is the ratio of the Emissions(in percent) of Costa Rica in 1985 to that in 1987?
Make the answer very short. 1. What is the ratio of the Emissions(in percent) of Lao PDR in 1985 to that in 1987?
Your answer should be compact. 1. What is the ratio of the Emissions(in percent) of Philippines in 1985 to that in 1987?
Keep it short and to the point. 0.97. What is the ratio of the Emissions(in percent) in Lao PDR in 1985 to that in 1988?
Provide a succinct answer. 1. What is the ratio of the Emissions(in percent) of Philippines in 1985 to that in 1988?
Your answer should be very brief. 0.97. What is the ratio of the Emissions(in percent) in Lao PDR in 1986 to that in 1987?
Your answer should be very brief. 1. What is the ratio of the Emissions(in percent) of Philippines in 1986 to that in 1987?
Make the answer very short. 0.99. What is the ratio of the Emissions(in percent) in Fragile and conflict affected situations in 1986 to that in 1988?
Make the answer very short. 0.95. What is the ratio of the Emissions(in percent) of Lao PDR in 1986 to that in 1988?
Ensure brevity in your answer.  1. What is the ratio of the Emissions(in percent) of Fragile and conflict affected situations in 1987 to that in 1988?
Keep it short and to the point. 0.96. What is the ratio of the Emissions(in percent) of Costa Rica in 1987 to that in 1988?
Your response must be concise. 0.99. What is the ratio of the Emissions(in percent) of Lao PDR in 1987 to that in 1988?
Keep it short and to the point. 1. What is the ratio of the Emissions(in percent) of Philippines in 1987 to that in 1988?
Make the answer very short. 1. What is the difference between the highest and the second highest Emissions(in percent) of Fragile and conflict affected situations?
Give a very brief answer. 0.85. What is the difference between the highest and the second highest Emissions(in percent) in Costa Rica?
Provide a short and direct response. 0.42. What is the difference between the highest and the second highest Emissions(in percent) of Lao PDR?
Your answer should be very brief. 0. What is the difference between the highest and the second highest Emissions(in percent) in Philippines?
Your response must be concise. 1.58. What is the difference between the highest and the lowest Emissions(in percent) of Fragile and conflict affected situations?
Provide a short and direct response. 6.84. What is the difference between the highest and the lowest Emissions(in percent) in Costa Rica?
Give a very brief answer. 2.66. What is the difference between the highest and the lowest Emissions(in percent) in Philippines?
Your answer should be very brief. 7.66. 